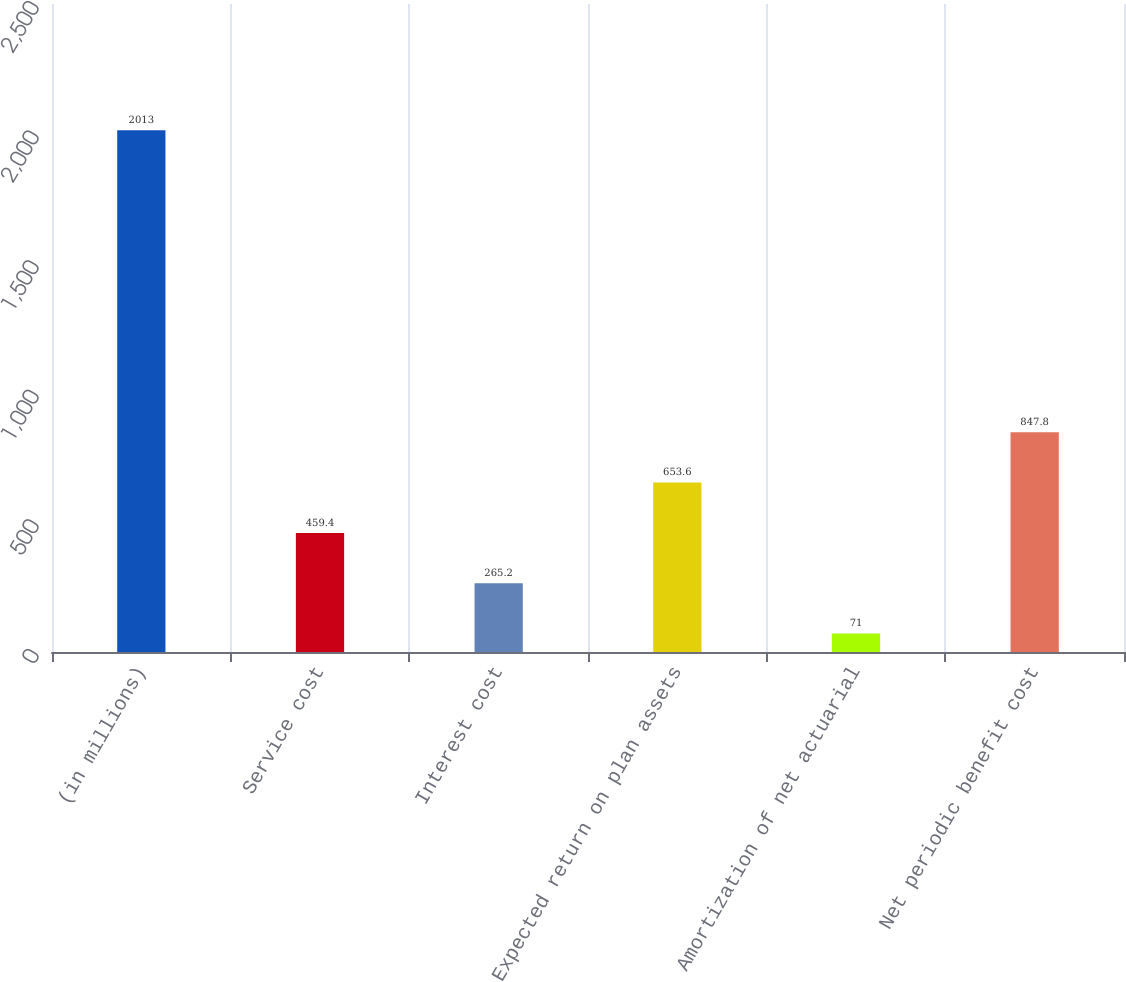Convert chart to OTSL. <chart><loc_0><loc_0><loc_500><loc_500><bar_chart><fcel>(in millions)<fcel>Service cost<fcel>Interest cost<fcel>Expected return on plan assets<fcel>Amortization of net actuarial<fcel>Net periodic benefit cost<nl><fcel>2013<fcel>459.4<fcel>265.2<fcel>653.6<fcel>71<fcel>847.8<nl></chart> 